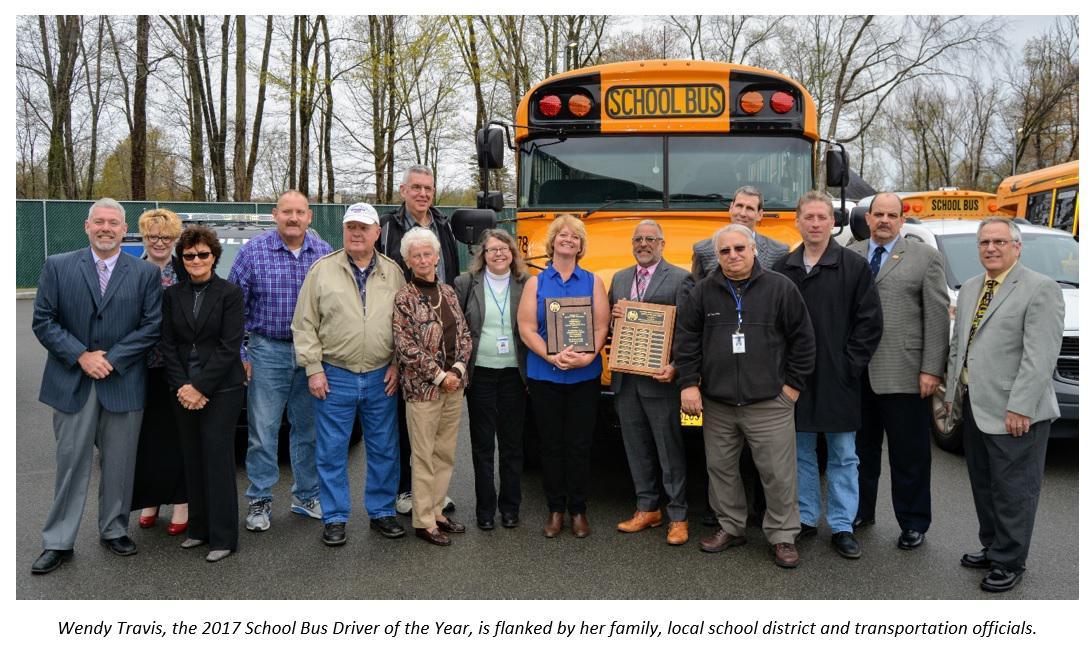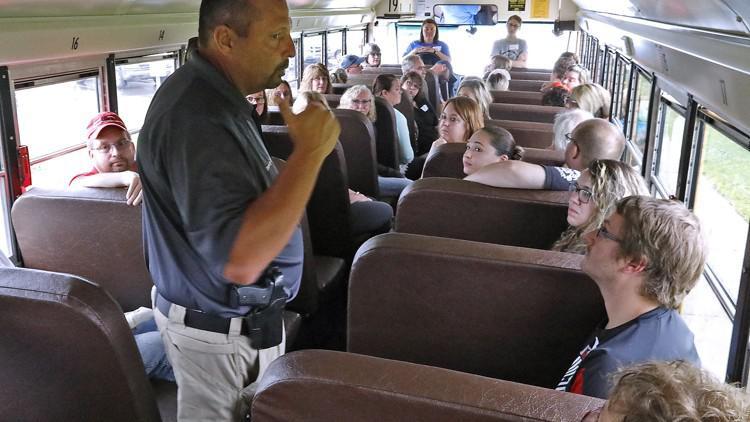The first image is the image on the left, the second image is the image on the right. For the images shown, is this caption "One image shows a blue tarp covering part of the crumpled side of a yellow bus." true? Answer yes or no. No. The first image is the image on the left, the second image is the image on the right. For the images shown, is this caption "A severely damaged school bus has a blue tarp hanging down the side." true? Answer yes or no. No. 